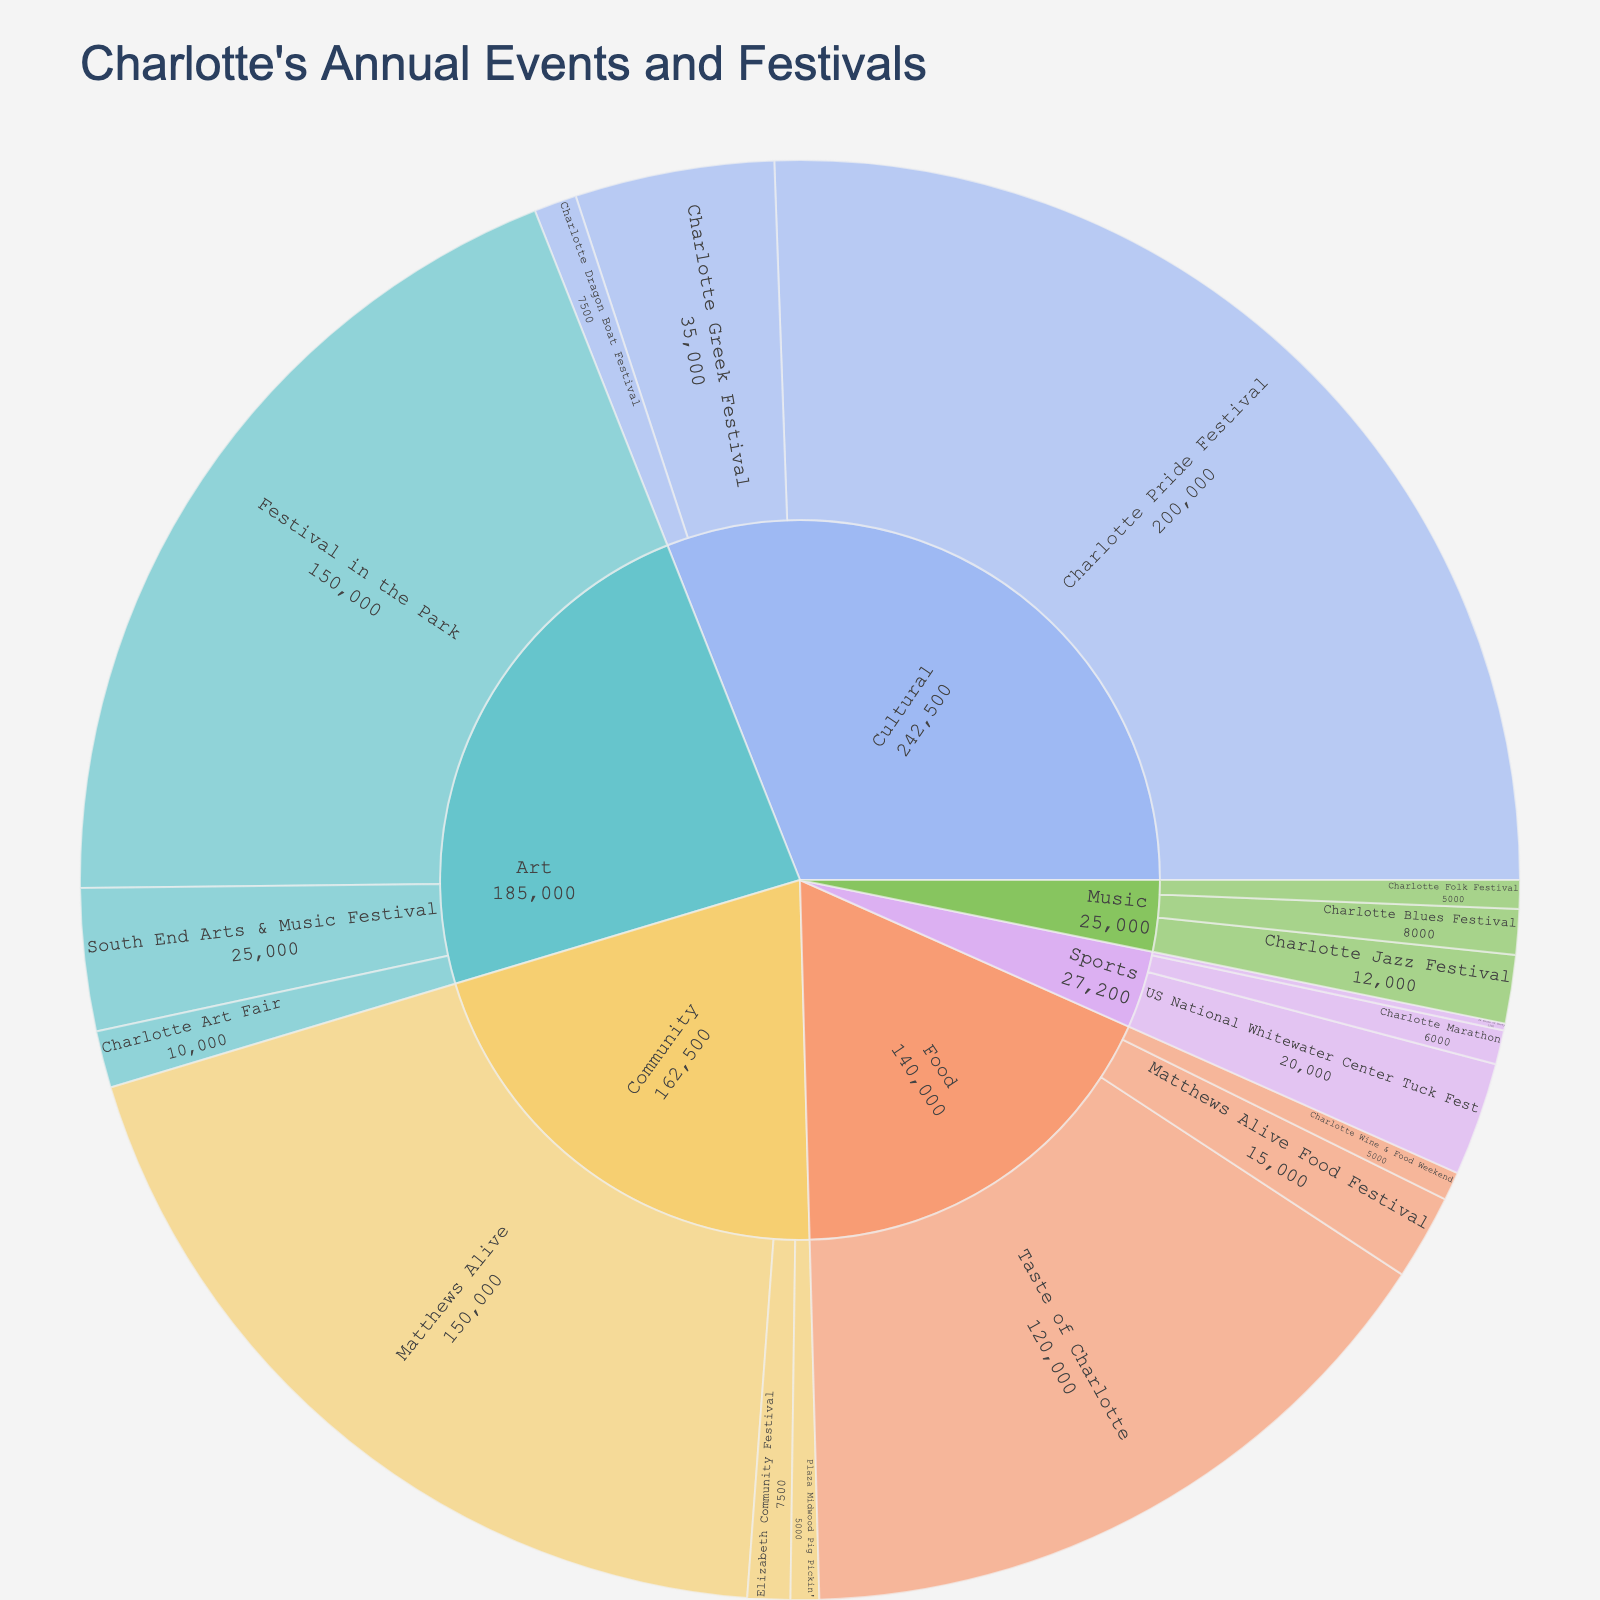What is the title of the sunburst plot? The title is typically displayed at the top of the plot. It provides an overview of the main subject of the display. Here, the title is "Charlotte's Annual Events and Festivals".
Answer: Charlotte's Annual Events and Festivals Which event has the highest attendance in the Cultural category? Look for the section labeled "Cultural" in the sunburst plot. Within this section, compare the attendance values for each event. The "Charlotte Pride Festival" has the highest attendance at 200,000.
Answer: Charlotte Pride Festival What is the total attendance for all Music events combined? Identify all Music events in the plot. Sum their attendance values: Charlotte Folk Festival (5,000) + Charlotte Jazz Festival (12,000) + Charlotte Blues Festival (8,000). 5,000 + 12,000 + 8,000 = 25,000.
Answer: 25,000 Which location hosts the Matthews Alive Food Festival? Locate the "Matthews Alive Food Festival" event within the Food category. Check the associated hover data for the location. The location is Downtown Matthews.
Answer: Downtown Matthews Is the attendance for the US National Whitewater Center Tuck Fest greater than the Matthews Alive Food Festival? Compare the attendance of both events. US National Whitewater Center Tuck Fest has 20,000 attendees. Matthews Alive Food Festival has 15,000 attendees. Since 20,000 > 15,000, the answer is yes.
Answer: Yes Which category has the fewest total events? Count the number of events in each category by looking at the branches of the sunburst plot. The category with the fewest events is Sports, which has three events.
Answer: Sports What is the average attendance for Community events? Identify the attendance for all Community events: Matthews Alive (150,000), Plaza Midwood Pig Pickin' (5,000), Elizabeth Community Festival (7,500). Calculate the average: (150,000 + 5,000 + 7,500) / 3 = 162,500 / 3 ≈ 54,167.
Answer: 54,167 How many events are located in Uptown Charlotte? Find events with "Uptown Charlotte" as the location: Charlotte Pride Festival and Charlotte Marathon. Count these identified events. There are two events located in Uptown Charlotte.
Answer: Two Which category has the highest total attendance? Sum the attendance for all events in each category and compare. Cultural (242,500), Music (25,000), Food (140,000), Art (185,000), Sports (27,200), Community (162,500). Cultural has the highest total attendance.
Answer: Cultural 